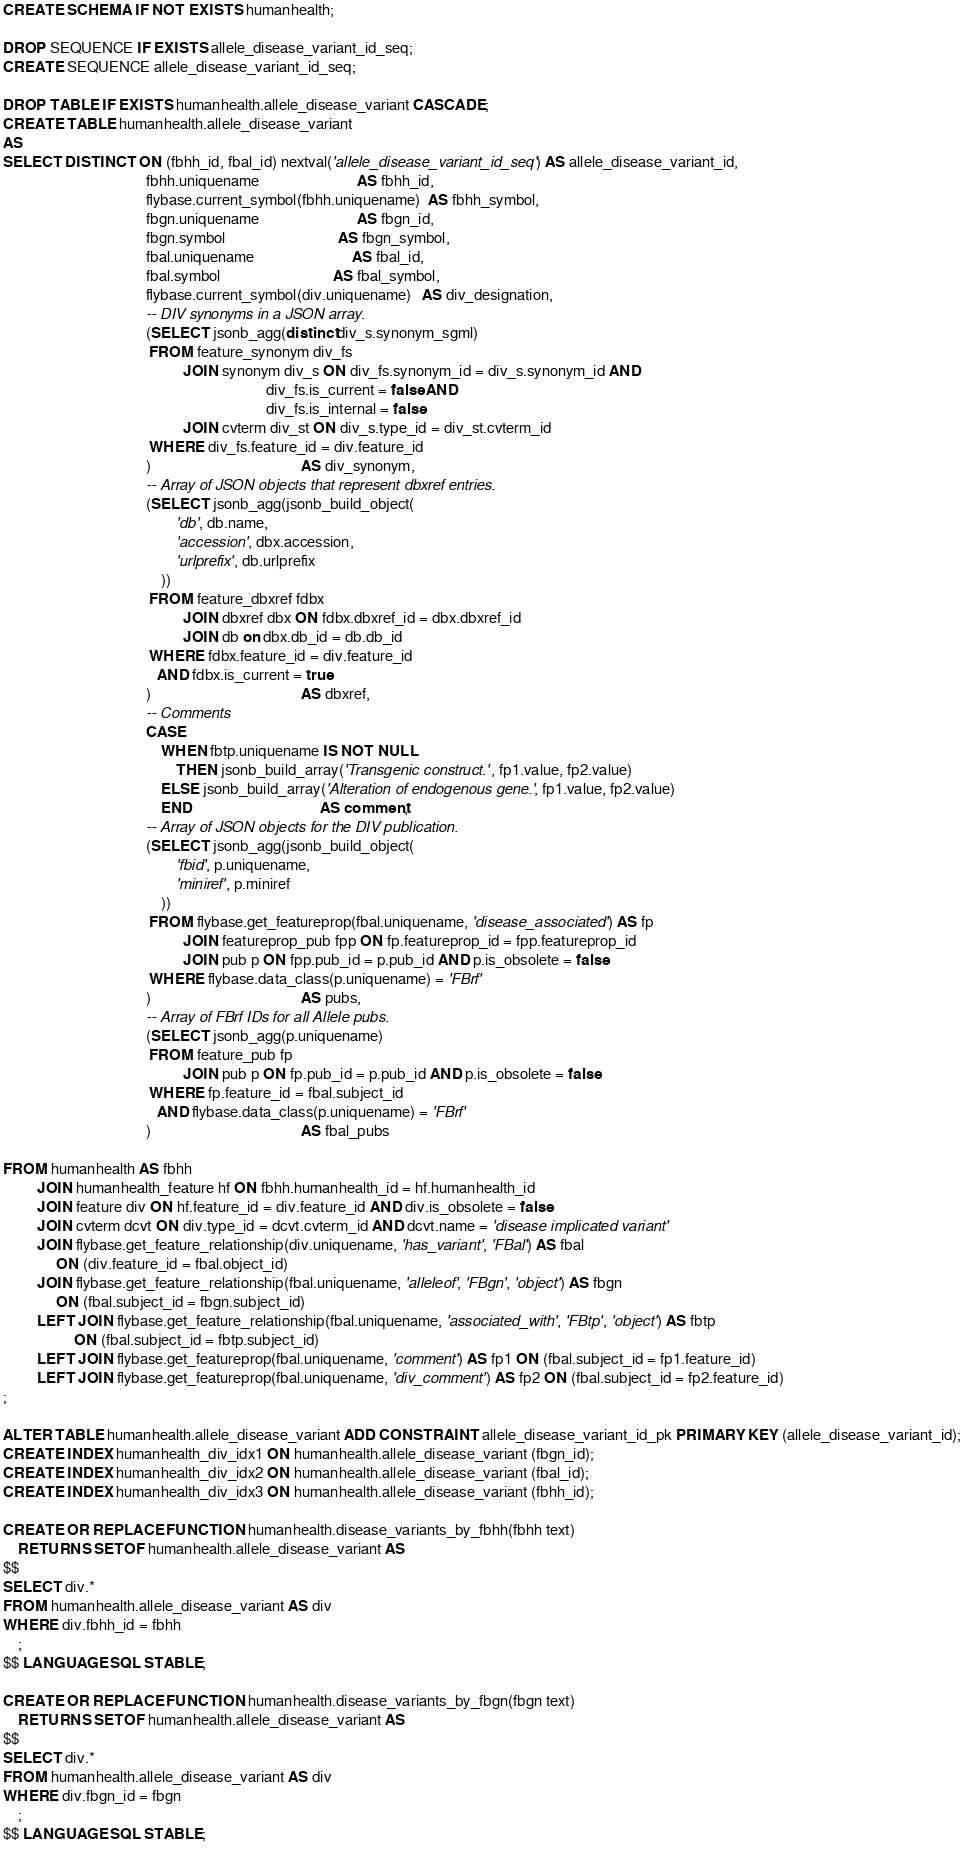<code> <loc_0><loc_0><loc_500><loc_500><_SQL_>CREATE SCHEMA IF NOT EXISTS humanhealth;

DROP SEQUENCE IF EXISTS allele_disease_variant_id_seq;
CREATE SEQUENCE allele_disease_variant_id_seq;

DROP TABLE IF EXISTS humanhealth.allele_disease_variant CASCADE;
CREATE TABLE humanhealth.allele_disease_variant
AS
SELECT DISTINCT ON (fbhh_id, fbal_id) nextval('allele_disease_variant_id_seq') AS allele_disease_variant_id,
                                      fbhh.uniquename                          AS fbhh_id,
                                      flybase.current_symbol(fbhh.uniquename)  AS fbhh_symbol,
                                      fbgn.uniquename                          AS fbgn_id,
                                      fbgn.symbol                              AS fbgn_symbol,
                                      fbal.uniquename                          AS fbal_id,
                                      fbal.symbol                              AS fbal_symbol,
                                      flybase.current_symbol(div.uniquename)   AS div_designation,
                                      -- DIV synonyms in a JSON array.
                                      (SELECT jsonb_agg(distinct div_s.synonym_sgml)
                                       FROM feature_synonym div_fs
                                                JOIN synonym div_s ON div_fs.synonym_id = div_s.synonym_id AND
                                                                      div_fs.is_current = false AND
                                                                      div_fs.is_internal = false
                                                JOIN cvterm div_st ON div_s.type_id = div_st.cvterm_id
                                       WHERE div_fs.feature_id = div.feature_id
                                      )                                        AS div_synonym,
                                      -- Array of JSON objects that represent dbxref entries.
                                      (SELECT jsonb_agg(jsonb_build_object(
                                              'db', db.name,
                                              'accession', dbx.accession,
                                              'urlprefix', db.urlprefix
                                          ))
                                       FROM feature_dbxref fdbx
                                                JOIN dbxref dbx ON fdbx.dbxref_id = dbx.dbxref_id
                                                JOIN db on dbx.db_id = db.db_id
                                       WHERE fdbx.feature_id = div.feature_id
                                         AND fdbx.is_current = true
                                      )                                        AS dbxref,
                                      -- Comments
                                      CASE
                                          WHEN fbtp.uniquename IS NOT NULL
                                              THEN jsonb_build_array('Transgenic construct.', fp1.value, fp2.value)
                                          ELSE jsonb_build_array('Alteration of endogenous gene.', fp1.value, fp2.value)
                                          END                                  AS comment,
                                      -- Array of JSON objects for the DIV publication.
                                      (SELECT jsonb_agg(jsonb_build_object(
                                              'fbid', p.uniquename,
                                              'miniref', p.miniref
                                          ))
                                       FROM flybase.get_featureprop(fbal.uniquename, 'disease_associated') AS fp
                                                JOIN featureprop_pub fpp ON fp.featureprop_id = fpp.featureprop_id
                                                JOIN pub p ON fpp.pub_id = p.pub_id AND p.is_obsolete = false
                                       WHERE flybase.data_class(p.uniquename) = 'FBrf'
                                      )                                        AS pubs,
                                      -- Array of FBrf IDs for all Allele pubs.
                                      (SELECT jsonb_agg(p.uniquename)
                                       FROM feature_pub fp
                                                JOIN pub p ON fp.pub_id = p.pub_id AND p.is_obsolete = false
                                       WHERE fp.feature_id = fbal.subject_id
                                         AND flybase.data_class(p.uniquename) = 'FBrf'
                                      )                                        AS fbal_pubs

FROM humanhealth AS fbhh
         JOIN humanhealth_feature hf ON fbhh.humanhealth_id = hf.humanhealth_id
         JOIN feature div ON hf.feature_id = div.feature_id AND div.is_obsolete = false
         JOIN cvterm dcvt ON div.type_id = dcvt.cvterm_id AND dcvt.name = 'disease implicated variant'
         JOIN flybase.get_feature_relationship(div.uniquename, 'has_variant', 'FBal') AS fbal
              ON (div.feature_id = fbal.object_id)
         JOIN flybase.get_feature_relationship(fbal.uniquename, 'alleleof', 'FBgn', 'object') AS fbgn
              ON (fbal.subject_id = fbgn.subject_id)
         LEFT JOIN flybase.get_feature_relationship(fbal.uniquename, 'associated_with', 'FBtp', 'object') AS fbtp
                   ON (fbal.subject_id = fbtp.subject_id)
         LEFT JOIN flybase.get_featureprop(fbal.uniquename, 'comment') AS fp1 ON (fbal.subject_id = fp1.feature_id)
         LEFT JOIN flybase.get_featureprop(fbal.uniquename, 'div_comment') AS fp2 ON (fbal.subject_id = fp2.feature_id)
;

ALTER TABLE humanhealth.allele_disease_variant ADD CONSTRAINT allele_disease_variant_id_pk PRIMARY KEY (allele_disease_variant_id);
CREATE INDEX humanhealth_div_idx1 ON humanhealth.allele_disease_variant (fbgn_id);
CREATE INDEX humanhealth_div_idx2 ON humanhealth.allele_disease_variant (fbal_id);
CREATE INDEX humanhealth_div_idx3 ON humanhealth.allele_disease_variant (fbhh_id);

CREATE OR REPLACE FUNCTION humanhealth.disease_variants_by_fbhh(fbhh text)
    RETURNS SETOF humanhealth.allele_disease_variant AS
$$
SELECT div.*
FROM humanhealth.allele_disease_variant AS div
WHERE div.fbhh_id = fbhh
    ;
$$ LANGUAGE SQL STABLE;

CREATE OR REPLACE FUNCTION humanhealth.disease_variants_by_fbgn(fbgn text)
    RETURNS SETOF humanhealth.allele_disease_variant AS
$$
SELECT div.*
FROM humanhealth.allele_disease_variant AS div
WHERE div.fbgn_id = fbgn
    ;
$$ LANGUAGE SQL STABLE;
</code> 